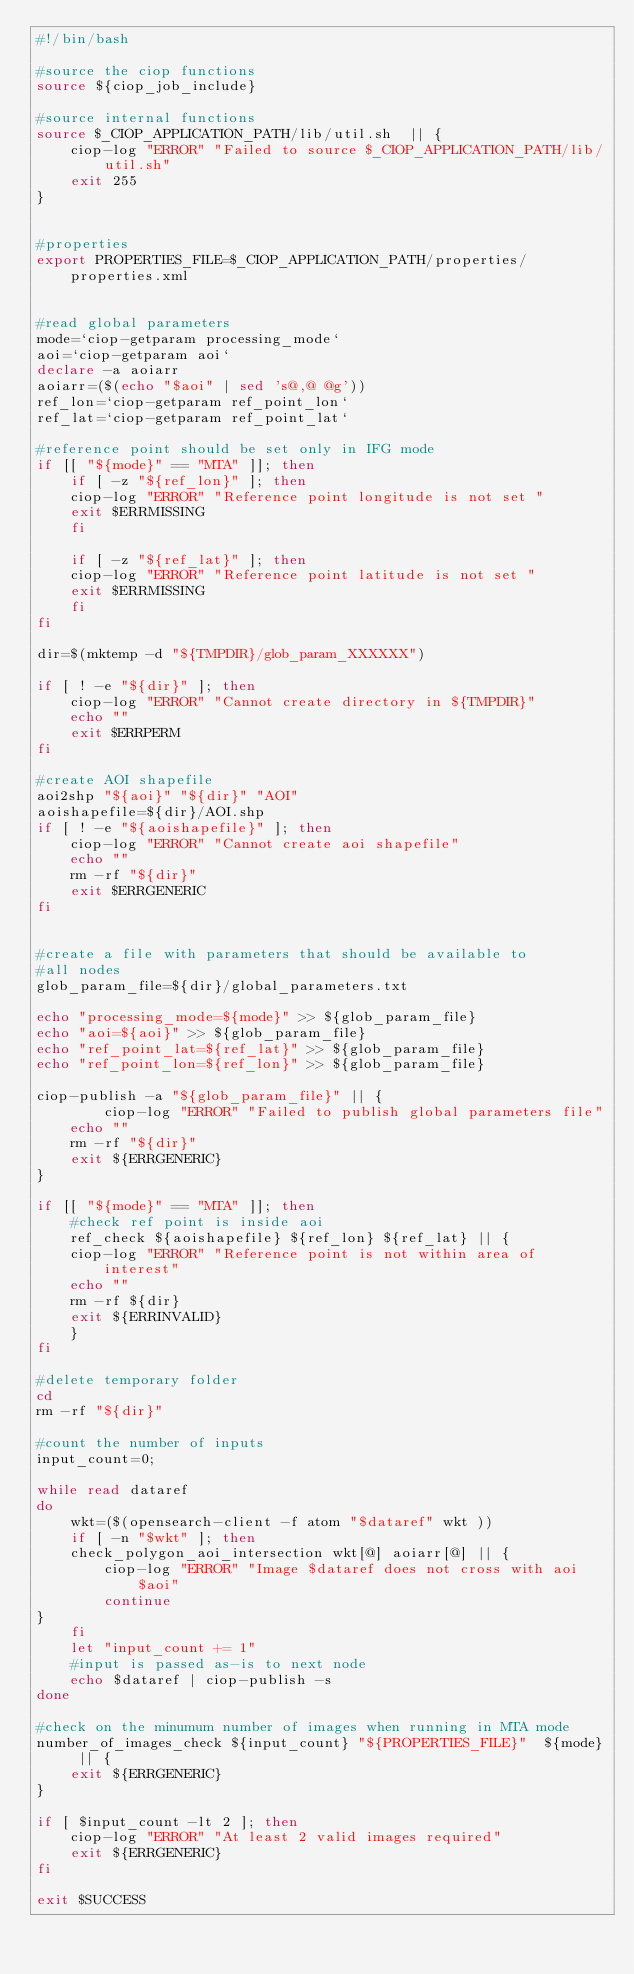Convert code to text. <code><loc_0><loc_0><loc_500><loc_500><_Bash_>#!/bin/bash

#source the ciop functions
source ${ciop_job_include}

#source internal functions
source $_CIOP_APPLICATION_PATH/lib/util.sh  || {
    ciop-log "ERROR" "Failed to source $_CIOP_APPLICATION_PATH/lib/util.sh"
    exit 255
}


#properties
export PROPERTIES_FILE=$_CIOP_APPLICATION_PATH/properties/properties.xml


#read global parameters
mode=`ciop-getparam processing_mode`
aoi=`ciop-getparam aoi`
declare -a aoiarr
aoiarr=($(echo "$aoi" | sed 's@,@ @g'))
ref_lon=`ciop-getparam ref_point_lon`
ref_lat=`ciop-getparam ref_point_lat`

#reference point should be set only in IFG mode
if [[ "${mode}" == "MTA" ]]; then
    if [ -z "${ref_lon}" ]; then
	ciop-log "ERROR" "Reference point longitude is not set "
	exit $ERRMISSING
    fi
    
    if [ -z "${ref_lat}" ]; then
	ciop-log "ERROR" "Reference point latitude is not set "
	exit $ERRMISSING
    fi
fi

dir=$(mktemp -d "${TMPDIR}/glob_param_XXXXXX")

if [ ! -e "${dir}" ]; then
    ciop-log "ERROR" "Cannot create directory in ${TMPDIR}"
    echo ""
    exit $ERRPERM
fi

#create AOI shapefile
aoi2shp "${aoi}" "${dir}" "AOI"
aoishapefile=${dir}/AOI.shp
if [ ! -e "${aoishapefile}" ]; then
    ciop-log "ERROR" "Cannot create aoi shapefile"
    echo ""
    rm -rf "${dir}"
    exit $ERRGENERIC
fi


#create a file with parameters that should be available to 
#all nodes
glob_param_file=${dir}/global_parameters.txt

echo "processing_mode=${mode}" >> ${glob_param_file}
echo "aoi=${aoi}" >> ${glob_param_file}
echo "ref_point_lat=${ref_lat}" >> ${glob_param_file}
echo "ref_point_lon=${ref_lon}" >> ${glob_param_file}

ciop-publish -a "${glob_param_file}" || {
    	ciop-log "ERROR" "Failed to publish global parameters file"
	echo ""
	rm -rf "${dir}"
	exit ${ERRGENERIC}
}

if [[ "${mode}" == "MTA" ]]; then
    #check ref point is inside aoi
    ref_check ${aoishapefile} ${ref_lon} ${ref_lat} || {
	ciop-log "ERROR" "Reference point is not within area of interest"
	echo ""
	rm -rf ${dir}
	exit ${ERRINVALID}
    }    
fi

#delete temporary folder
cd 
rm -rf "${dir}"

#count the number of inputs
input_count=0;

while read dataref
do
    wkt=($(opensearch-client -f atom "$dataref" wkt ))
    if [ -n "$wkt" ]; then
	check_polygon_aoi_intersection wkt[@] aoiarr[@] || {
	    ciop-log "ERROR" "Image $dataref does not cross with aoi $aoi"
	    continue
}
    fi
    let "input_count += 1"
    #input is passed as-is to next node
    echo $dataref | ciop-publish -s
done

#check on the minumum number of images when running in MTA mode
number_of_images_check ${input_count} "${PROPERTIES_FILE}"  ${mode} || {
    exit ${ERRGENERIC}
}

if [ $input_count -lt 2 ]; then
    ciop-log "ERROR" "At least 2 valid images required"
    exit ${ERRGENERIC}
fi

exit $SUCCESS
</code> 